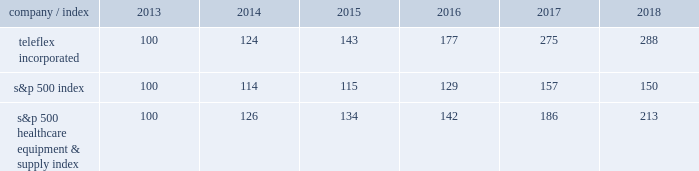Part a0ii item a05 .
Market for registrant 2019s common equity , related stockholder matters and issuer purchases of equity securities our common stock is listed on the new york stock exchange under the symbol 201ctfx . 201d as of february 19 , 2019 , we had 473 holders of record of our common stock .
A substantially greater number of holders of our common stock are beneficial owners whose shares are held by brokers and other financial institutions for the accounts of beneficial owners .
Stock performance graph the following graph provides a comparison of five year cumulative total stockholder returns of teleflex common stock , the standard a0& poor 2019s ( s&p ) 500 stock index and the s&p 500 healthcare equipment & supply index .
The annual changes for the five-year period shown on the graph are based on the assumption that $ 100 had been invested in teleflex common stock and each index on december a031 , 2013 and that all dividends were reinvested .
Market performance .
S&p 500 healthcare equipment & supply index 100 126 134 142 186 213 .
What is the roi of an investment in teleflex incorporated from 2013 to 2014? 
Computations: ((124 - 100) / 100)
Answer: 0.24. Part a0ii item a05 .
Market for registrant 2019s common equity , related stockholder matters and issuer purchases of equity securities our common stock is listed on the new york stock exchange under the symbol 201ctfx . 201d as of february 19 , 2019 , we had 473 holders of record of our common stock .
A substantially greater number of holders of our common stock are beneficial owners whose shares are held by brokers and other financial institutions for the accounts of beneficial owners .
Stock performance graph the following graph provides a comparison of five year cumulative total stockholder returns of teleflex common stock , the standard a0& poor 2019s ( s&p ) 500 stock index and the s&p 500 healthcare equipment & supply index .
The annual changes for the five-year period shown on the graph are based on the assumption that $ 100 had been invested in teleflex common stock and each index on december a031 , 2013 and that all dividends were reinvested .
Market performance .
S&p 500 healthcare equipment & supply index 100 126 134 142 186 213 .
What is the roi of an investment in teleflex incorporated from 2014 to 2015? 
Computations: ((143 - 124) / 124)
Answer: 0.15323. Part a0ii item a05 .
Market for registrant 2019s common equity , related stockholder matters and issuer purchases of equity securities our common stock is listed on the new york stock exchange under the symbol 201ctfx . 201d as of february 19 , 2019 , we had 473 holders of record of our common stock .
A substantially greater number of holders of our common stock are beneficial owners whose shares are held by brokers and other financial institutions for the accounts of beneficial owners .
Stock performance graph the following graph provides a comparison of five year cumulative total stockholder returns of teleflex common stock , the standard a0& poor 2019s ( s&p ) 500 stock index and the s&p 500 healthcare equipment & supply index .
The annual changes for the five-year period shown on the graph are based on the assumption that $ 100 had been invested in teleflex common stock and each index on december a031 , 2013 and that all dividends were reinvested .
Market performance .
S&p 500 healthcare equipment & supply index 100 126 134 142 186 213 .
What was the percentage increase for teleflex incorporated's market performance from 2014-2015? 
Computations: ((143 - 124) / 124)
Answer: 0.15323. 